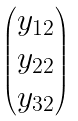Convert formula to latex. <formula><loc_0><loc_0><loc_500><loc_500>\begin{pmatrix} y _ { 1 2 } \\ y _ { 2 2 } \\ y _ { 3 2 } \end{pmatrix}</formula> 